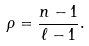<formula> <loc_0><loc_0><loc_500><loc_500>\rho = \frac { n - 1 } { \ell - 1 } .</formula> 